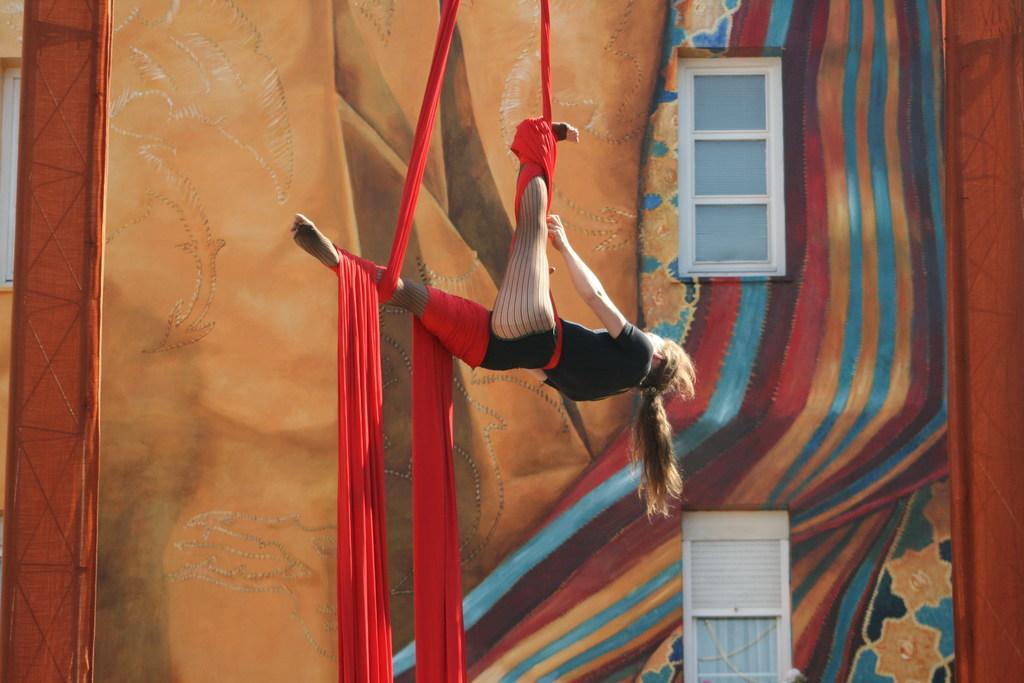How would you summarize this image in a sentence or two? In the image there is a lady hanging with the red cloth in the air. Behind her there is a wall with paintings and also there are windows. 